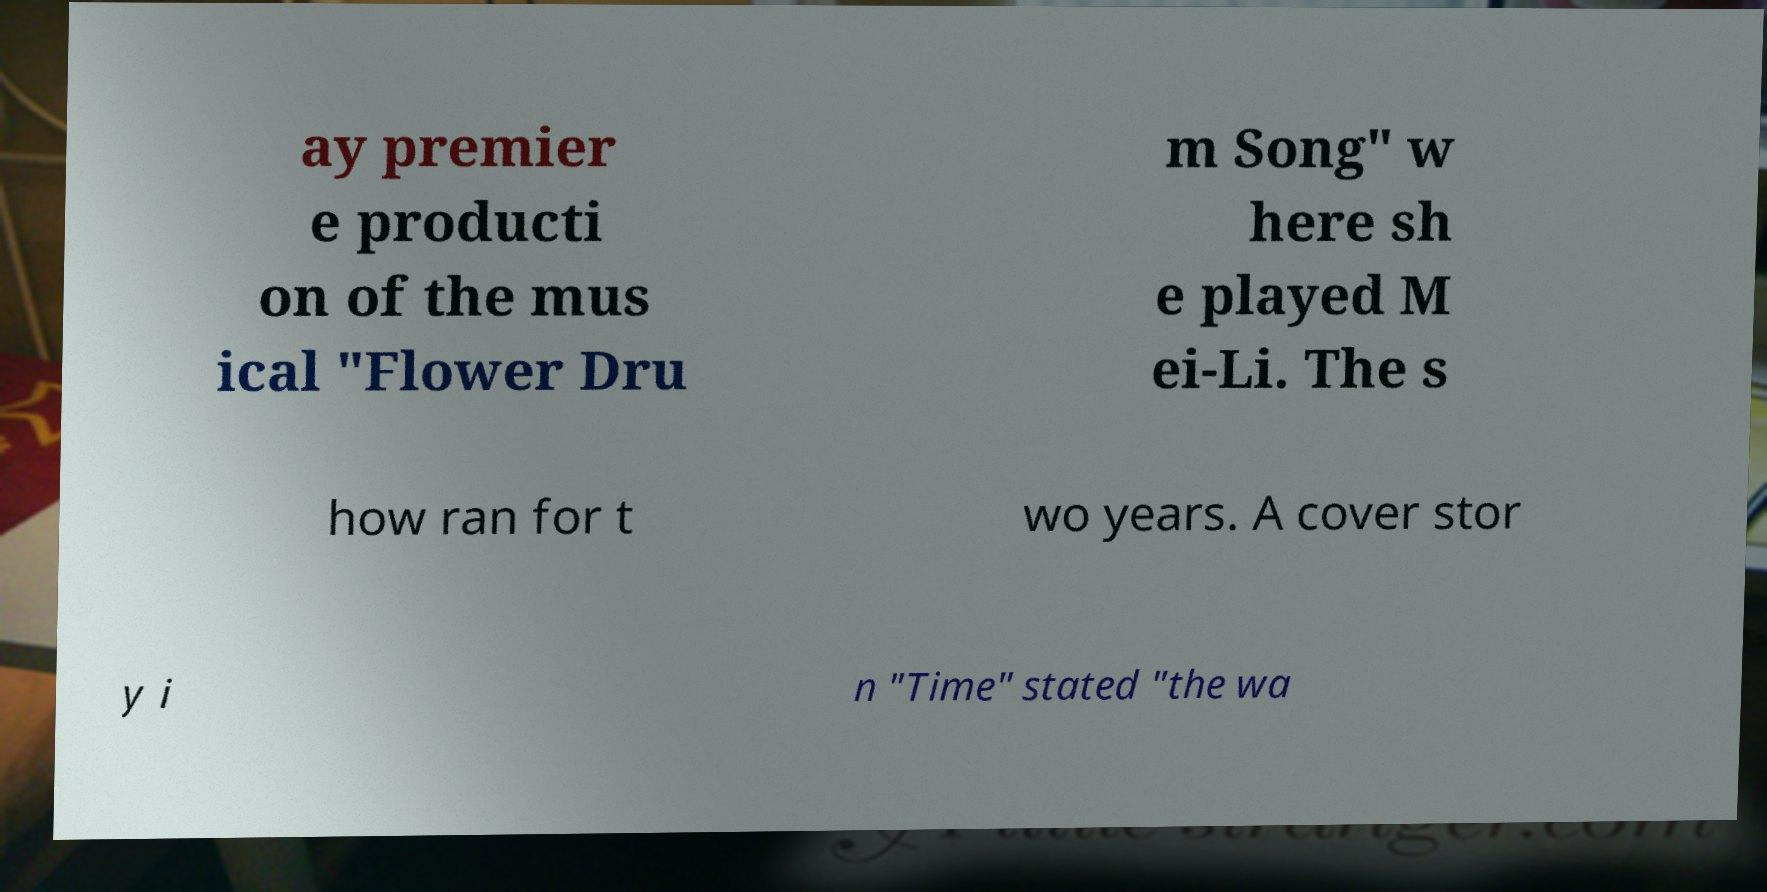Please read and relay the text visible in this image. What does it say? ay premier e producti on of the mus ical "Flower Dru m Song" w here sh e played M ei-Li. The s how ran for t wo years. A cover stor y i n "Time" stated "the wa 